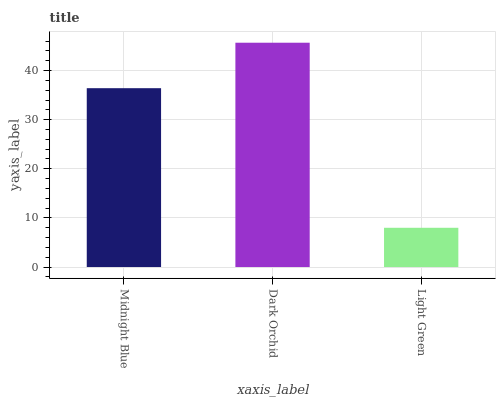Is Light Green the minimum?
Answer yes or no. Yes. Is Dark Orchid the maximum?
Answer yes or no. Yes. Is Dark Orchid the minimum?
Answer yes or no. No. Is Light Green the maximum?
Answer yes or no. No. Is Dark Orchid greater than Light Green?
Answer yes or no. Yes. Is Light Green less than Dark Orchid?
Answer yes or no. Yes. Is Light Green greater than Dark Orchid?
Answer yes or no. No. Is Dark Orchid less than Light Green?
Answer yes or no. No. Is Midnight Blue the high median?
Answer yes or no. Yes. Is Midnight Blue the low median?
Answer yes or no. Yes. Is Light Green the high median?
Answer yes or no. No. Is Dark Orchid the low median?
Answer yes or no. No. 